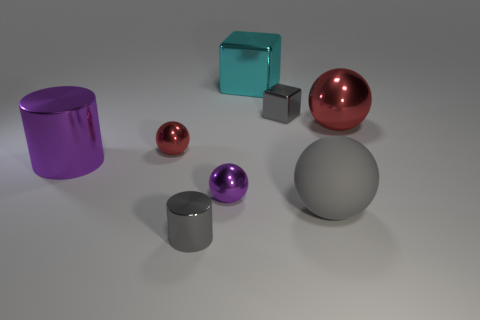Add 1 big gray things. How many objects exist? 9 Subtract all shiny spheres. How many spheres are left? 1 Subtract all cyan cubes. How many cubes are left? 1 Subtract 1 cylinders. How many cylinders are left? 1 Add 2 tiny metal things. How many tiny metal things are left? 6 Add 5 large red things. How many large red things exist? 6 Subtract 0 yellow blocks. How many objects are left? 8 Subtract all blocks. How many objects are left? 6 Subtract all green cubes. Subtract all yellow cylinders. How many cubes are left? 2 Subtract all green balls. How many blue cylinders are left? 0 